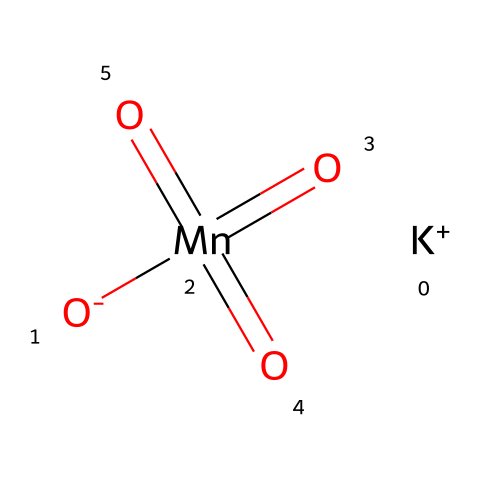What is the central atom in potassium permanganate? The central atom can be identified by locating the element that is bonded to multiple oxygen atoms and carries a positive oxidation state, which is manganese (Mn).
Answer: manganese How many oxygen atoms are bonded to the manganese atom? From the SMILES representation, it shows manganese bonded to four oxygen atoms, indicated by the notation (O) surrounding the Mn.
Answer: four What is the oxidation state of the manganese atom in this compound? The oxidation state can be deduced from the total number of bonds and the charges shown. Manganese has a +7 oxidation state, as it has 4 double bonds with oxygen and is in the +1 position with potassium present.
Answer: +7 Is potassium permanganate considered an oxidizer? Yes, as indicated by its molecular structure and the presence of high oxidation states, which is characteristic of oxidizers that facilitate electron transfer.
Answer: yes How many total atoms are present in the potassium permanganate molecule? By counting the number of individual atoms represented, there are one potassium atom, one manganese atom, and four oxygen atoms, totaling six atoms in the molecule.
Answer: six What kind of bonds are present between manganese and oxygen atoms? The bonds are primarily double bonds between manganese and the oxygen atoms, which are clearly indicated in the structure.
Answer: double bonds 